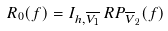Convert formula to latex. <formula><loc_0><loc_0><loc_500><loc_500>R _ { 0 } ( f ) = I _ { h , \overline { V _ { 1 } } } \, R P _ { \overline { V } _ { 2 } } ( f )</formula> 